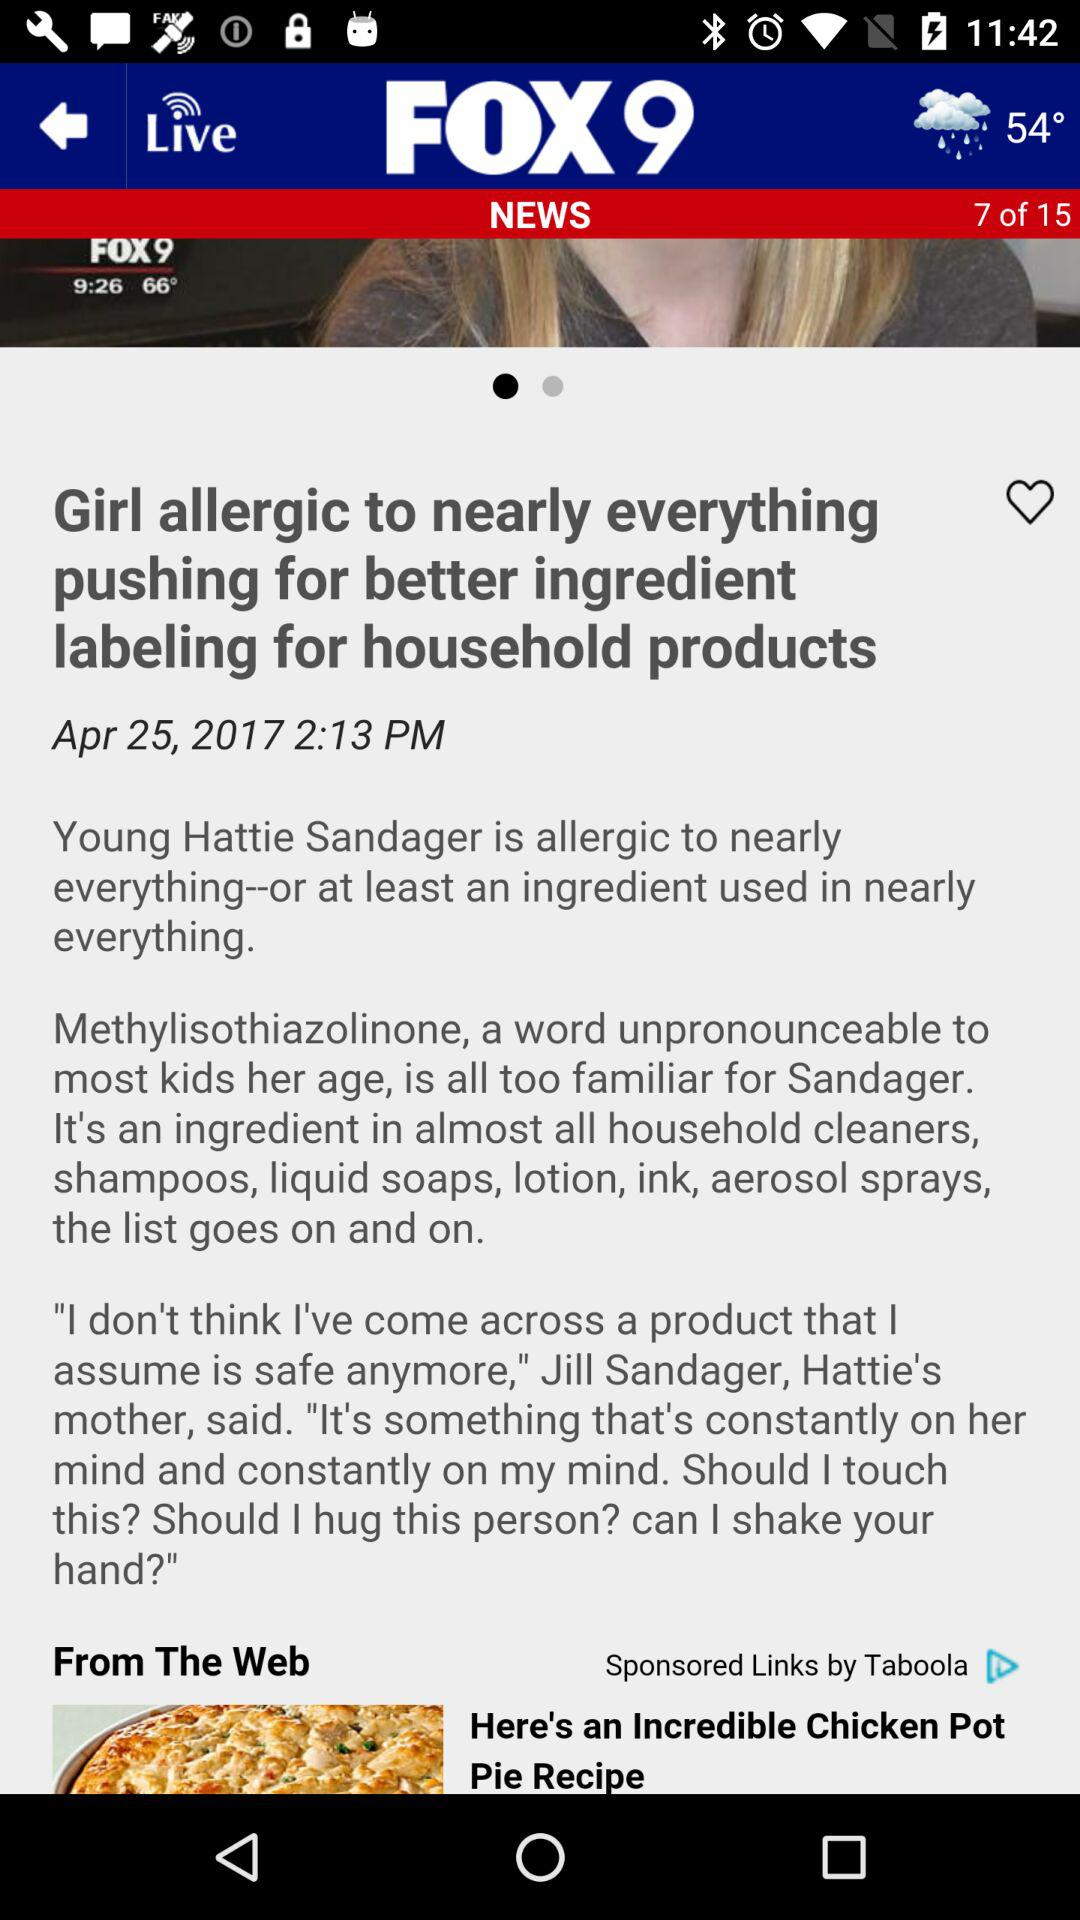What is the mentioned date and time of the news? The mentioned date and time is April 25, 2017 at 2:13 PM. 